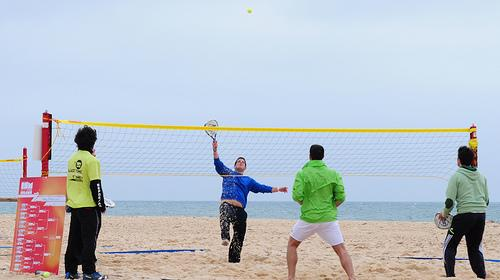Identify the color of the shirt worn by the man at the left-top corner of the image. The man at the left-top corner is wearing a yellow and black shirt. State the type of game being played by the people in the image, and the object being used. The people are playing beach volleyball, and they are using a yellow volleyball. 